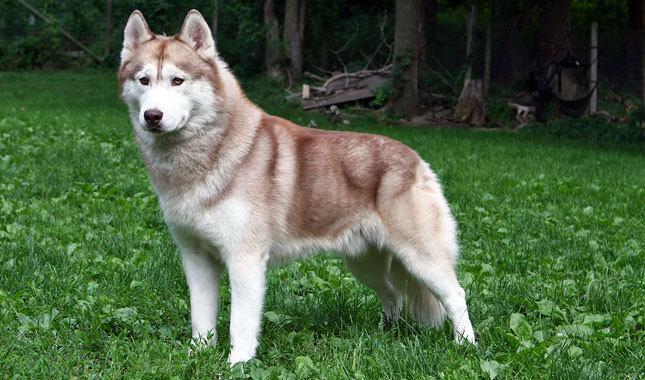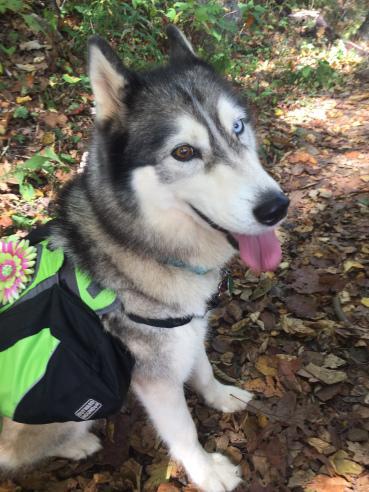The first image is the image on the left, the second image is the image on the right. Evaluate the accuracy of this statement regarding the images: "There are three dogs.". Is it true? Answer yes or no. No. 